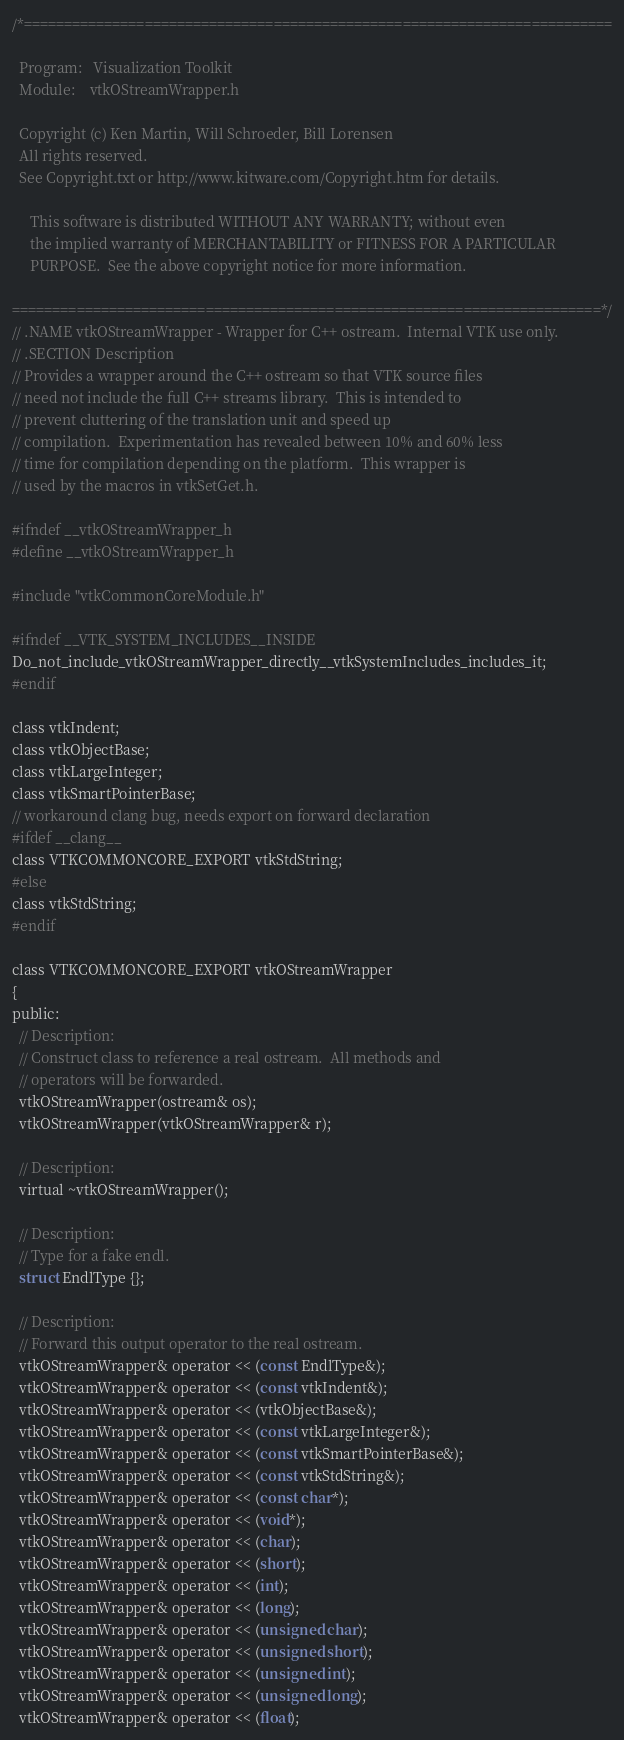<code> <loc_0><loc_0><loc_500><loc_500><_C_>/*=========================================================================

  Program:   Visualization Toolkit
  Module:    vtkOStreamWrapper.h

  Copyright (c) Ken Martin, Will Schroeder, Bill Lorensen
  All rights reserved.
  See Copyright.txt or http://www.kitware.com/Copyright.htm for details.

     This software is distributed WITHOUT ANY WARRANTY; without even
     the implied warranty of MERCHANTABILITY or FITNESS FOR A PARTICULAR
     PURPOSE.  See the above copyright notice for more information.

=========================================================================*/
// .NAME vtkOStreamWrapper - Wrapper for C++ ostream.  Internal VTK use only.
// .SECTION Description
// Provides a wrapper around the C++ ostream so that VTK source files
// need not include the full C++ streams library.  This is intended to
// prevent cluttering of the translation unit and speed up
// compilation.  Experimentation has revealed between 10% and 60% less
// time for compilation depending on the platform.  This wrapper is
// used by the macros in vtkSetGet.h.

#ifndef __vtkOStreamWrapper_h
#define __vtkOStreamWrapper_h

#include "vtkCommonCoreModule.h"

#ifndef __VTK_SYSTEM_INCLUDES__INSIDE
Do_not_include_vtkOStreamWrapper_directly__vtkSystemIncludes_includes_it;
#endif

class vtkIndent;
class vtkObjectBase;
class vtkLargeInteger;
class vtkSmartPointerBase;
// workaround clang bug, needs export on forward declaration
#ifdef __clang__
class VTKCOMMONCORE_EXPORT vtkStdString;
#else
class vtkStdString;
#endif

class VTKCOMMONCORE_EXPORT vtkOStreamWrapper
{
public:
  // Description:
  // Construct class to reference a real ostream.  All methods and
  // operators will be forwarded.
  vtkOStreamWrapper(ostream& os);
  vtkOStreamWrapper(vtkOStreamWrapper& r);

  // Description:
  virtual ~vtkOStreamWrapper();

  // Description:
  // Type for a fake endl.
  struct EndlType {};

  // Description:
  // Forward this output operator to the real ostream.
  vtkOStreamWrapper& operator << (const EndlType&);
  vtkOStreamWrapper& operator << (const vtkIndent&);
  vtkOStreamWrapper& operator << (vtkObjectBase&);
  vtkOStreamWrapper& operator << (const vtkLargeInteger&);
  vtkOStreamWrapper& operator << (const vtkSmartPointerBase&);
  vtkOStreamWrapper& operator << (const vtkStdString&);
  vtkOStreamWrapper& operator << (const char*);
  vtkOStreamWrapper& operator << (void*);
  vtkOStreamWrapper& operator << (char);
  vtkOStreamWrapper& operator << (short);
  vtkOStreamWrapper& operator << (int);
  vtkOStreamWrapper& operator << (long);
  vtkOStreamWrapper& operator << (unsigned char);
  vtkOStreamWrapper& operator << (unsigned short);
  vtkOStreamWrapper& operator << (unsigned int);
  vtkOStreamWrapper& operator << (unsigned long);
  vtkOStreamWrapper& operator << (float);</code> 